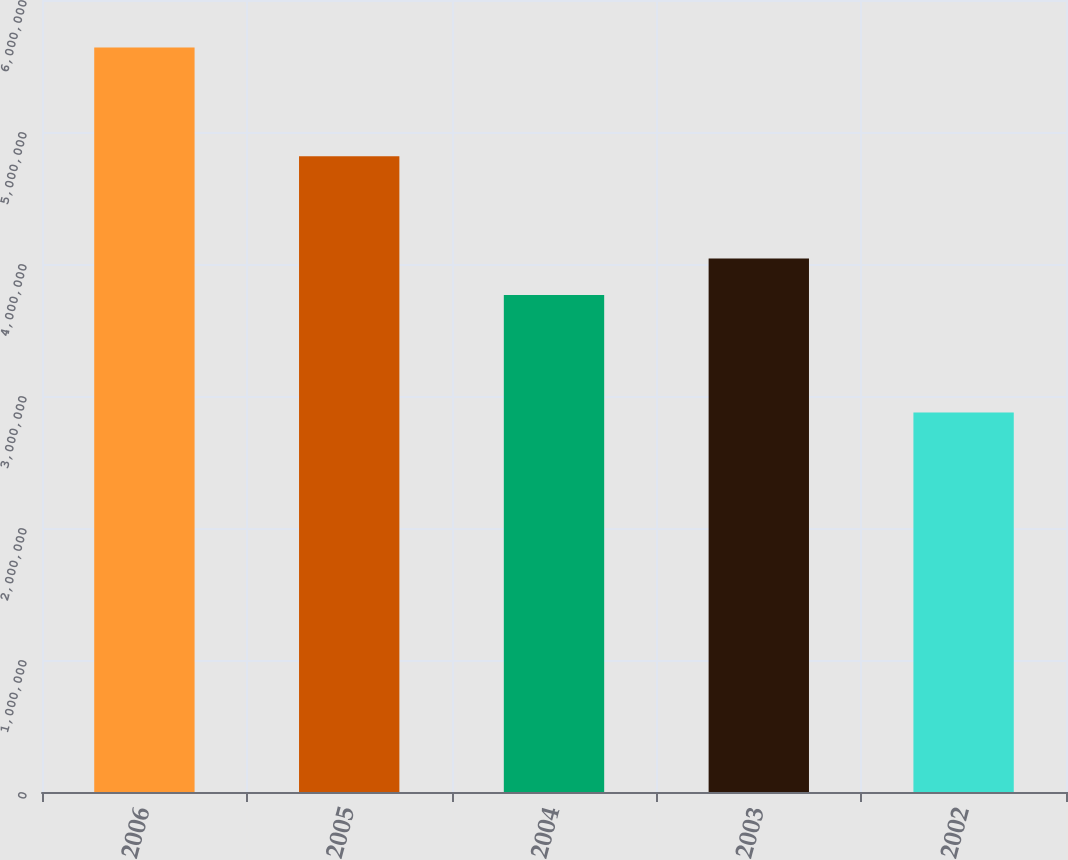Convert chart. <chart><loc_0><loc_0><loc_500><loc_500><bar_chart><fcel>2006<fcel>2005<fcel>2004<fcel>2003<fcel>2002<nl><fcel>5.64e+06<fcel>4.817e+06<fcel>3.766e+06<fcel>4.0425e+06<fcel>2.875e+06<nl></chart> 